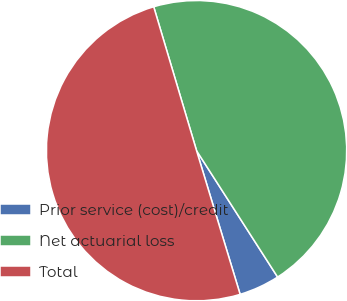Convert chart to OTSL. <chart><loc_0><loc_0><loc_500><loc_500><pie_chart><fcel>Prior service (cost)/credit<fcel>Net actuarial loss<fcel>Total<nl><fcel>4.39%<fcel>45.53%<fcel>50.08%<nl></chart> 